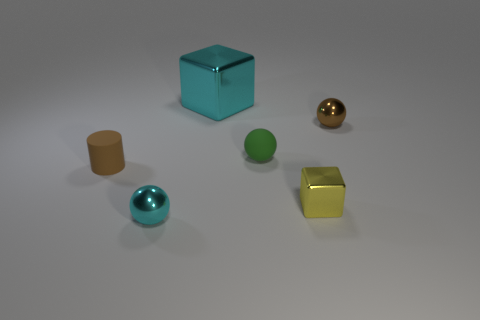What color is the tiny metallic sphere on the left side of the brown metal sphere?
Provide a short and direct response. Cyan. What size is the brown cylinder that is the same material as the tiny green ball?
Provide a short and direct response. Small. There is a green sphere; is it the same size as the shiny sphere that is in front of the yellow metal cube?
Give a very brief answer. Yes. What is the material of the cyan thing that is in front of the big cyan metallic object?
Keep it short and to the point. Metal. There is a block in front of the green rubber sphere; how many small spheres are in front of it?
Your response must be concise. 1. Is there a cyan metal thing that has the same shape as the small brown matte object?
Give a very brief answer. No. There is a object behind the brown sphere; is it the same size as the cube that is to the right of the rubber sphere?
Offer a very short reply. No. What is the shape of the small matte thing that is left of the metallic sphere in front of the brown metal ball?
Provide a succinct answer. Cylinder. What number of shiny balls have the same size as the green thing?
Offer a very short reply. 2. Are any large green metal blocks visible?
Your answer should be compact. No. 